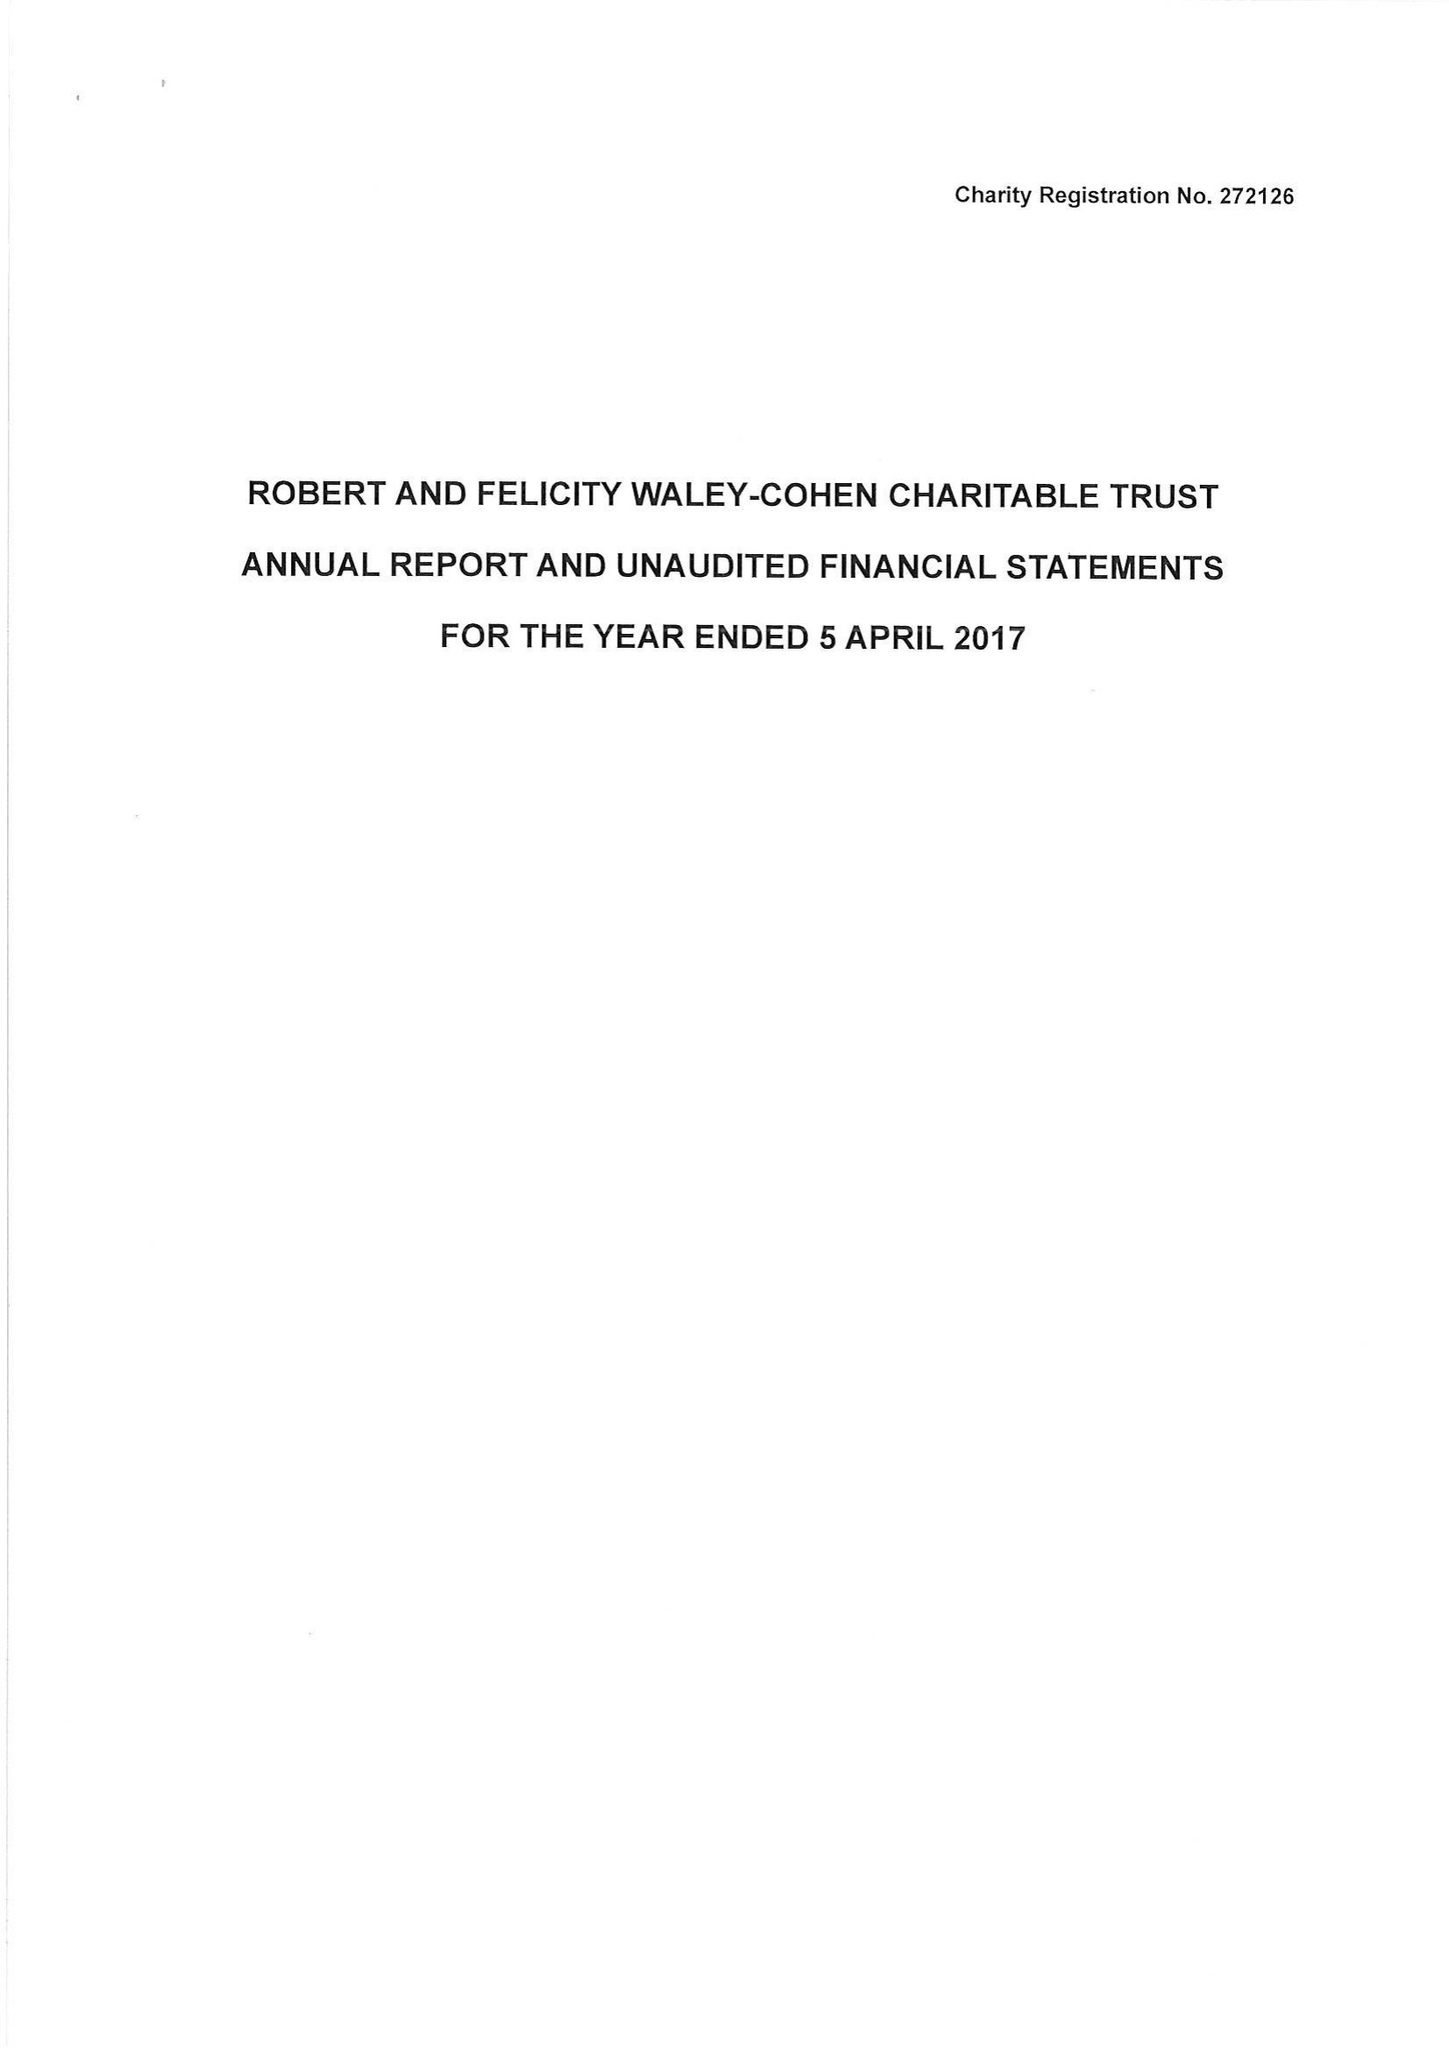What is the value for the address__street_line?
Answer the question using a single word or phrase. 27 SOUTH TERRACE 